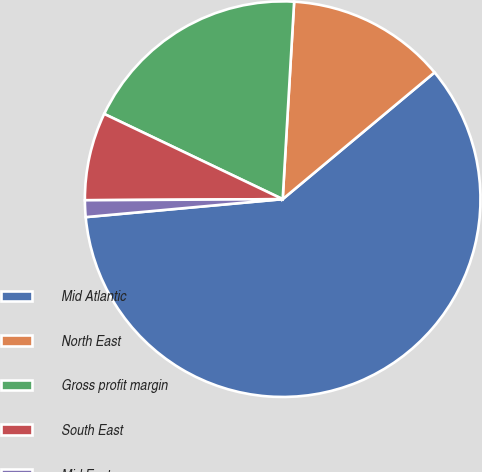Convert chart to OTSL. <chart><loc_0><loc_0><loc_500><loc_500><pie_chart><fcel>Mid Atlantic<fcel>North East<fcel>Gross profit margin<fcel>South East<fcel>Mid East<nl><fcel>59.62%<fcel>13.01%<fcel>18.83%<fcel>7.18%<fcel>1.36%<nl></chart> 